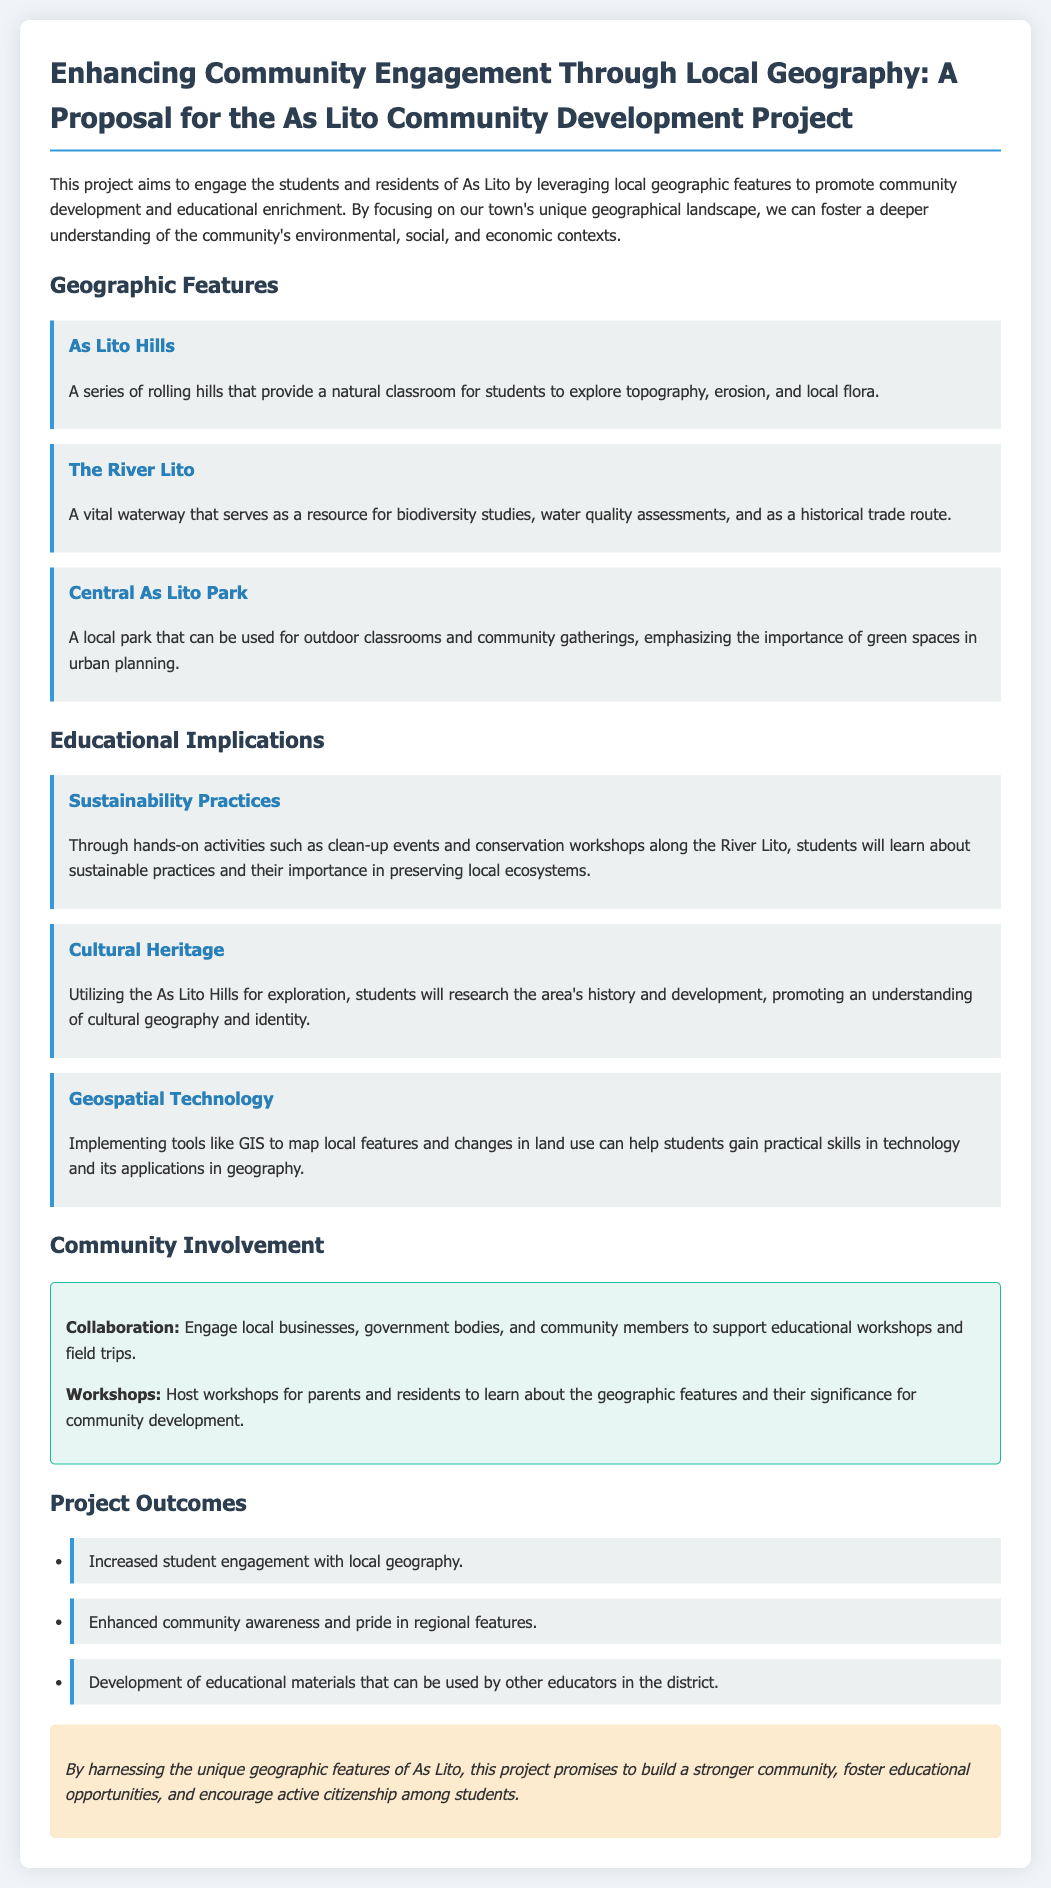What is the title of the project proposal? The title of the project proposal is presented prominently at the top of the document.
Answer: Enhancing Community Engagement Through Local Geography: A Proposal for the As Lito Community Development Project What is one of the geographic features mentioned in the document? The document lists various geographic features that serve as focal points for the project.
Answer: As Lito Hills What type of outdoor location is mentioned for community gatherings? The document specifies a local park that can be utilized for various community activities.
Answer: Central As Lito Park What kind of technology is mentioned for mapping local features? The document references a specific technology that aids in practical skills and geography.
Answer: GIS What is one outcome of the project? The document outlines specific outcomes that are expected from the project.
Answer: Increased student engagement with local geography Which specific environmental activity is suggested along the River Lito? The document describes hands-on activities that students will participate in for learning purposes.
Answer: Clean-up events What is a focus of the educational implications regarding local hills? The document discusses the importance of understanding a specific aspect of local geography.
Answer: Cultural Heritage Who are the stakeholders mentioned for collaboration? The document identifies groups that are encouraged to take part in supporting the project.
Answer: Local businesses, government bodies, and community members 